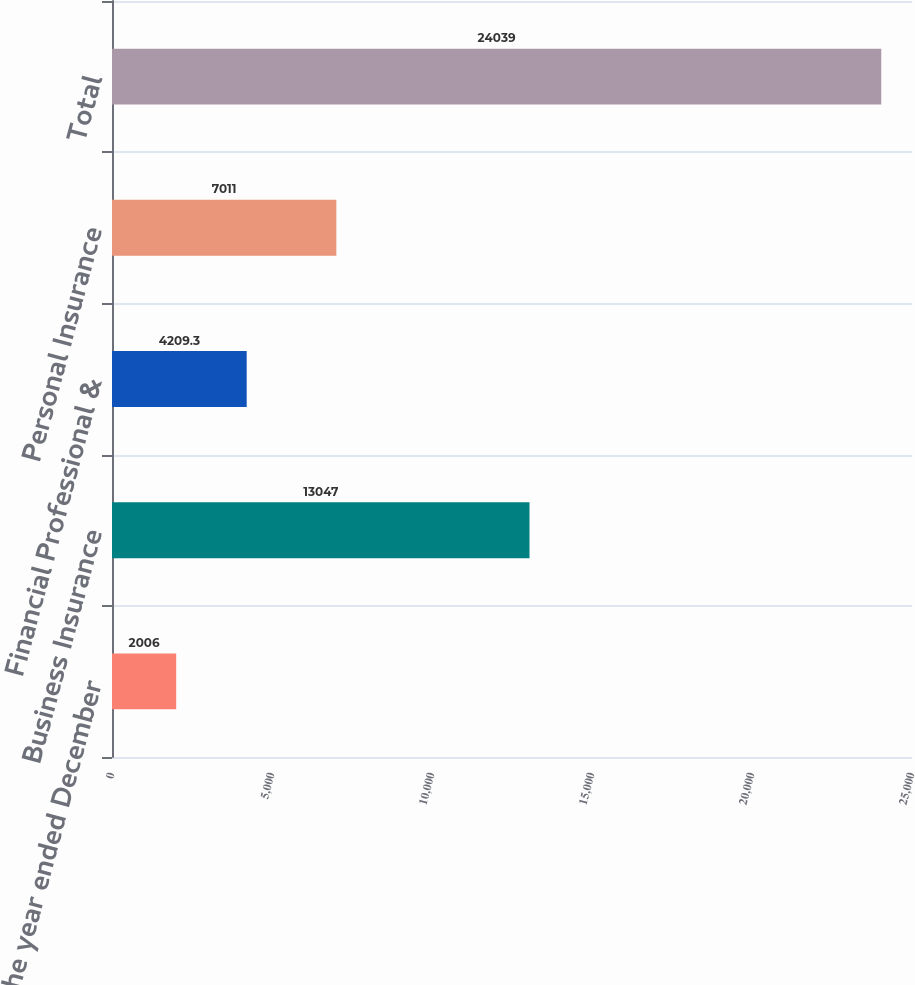Convert chart. <chart><loc_0><loc_0><loc_500><loc_500><bar_chart><fcel>(for the year ended December<fcel>Business Insurance<fcel>Financial Professional &<fcel>Personal Insurance<fcel>Total<nl><fcel>2006<fcel>13047<fcel>4209.3<fcel>7011<fcel>24039<nl></chart> 